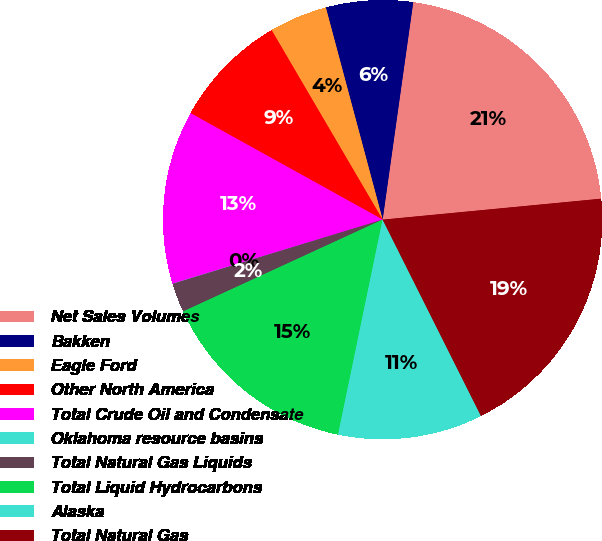<chart> <loc_0><loc_0><loc_500><loc_500><pie_chart><fcel>Net Sales Volumes<fcel>Bakken<fcel>Eagle Ford<fcel>Other North America<fcel>Total Crude Oil and Condensate<fcel>Oklahoma resource basins<fcel>Total Natural Gas Liquids<fcel>Total Liquid Hydrocarbons<fcel>Alaska<fcel>Total Natural Gas<nl><fcel>21.25%<fcel>6.39%<fcel>4.27%<fcel>8.51%<fcel>12.76%<fcel>0.02%<fcel>2.14%<fcel>14.88%<fcel>10.64%<fcel>19.13%<nl></chart> 